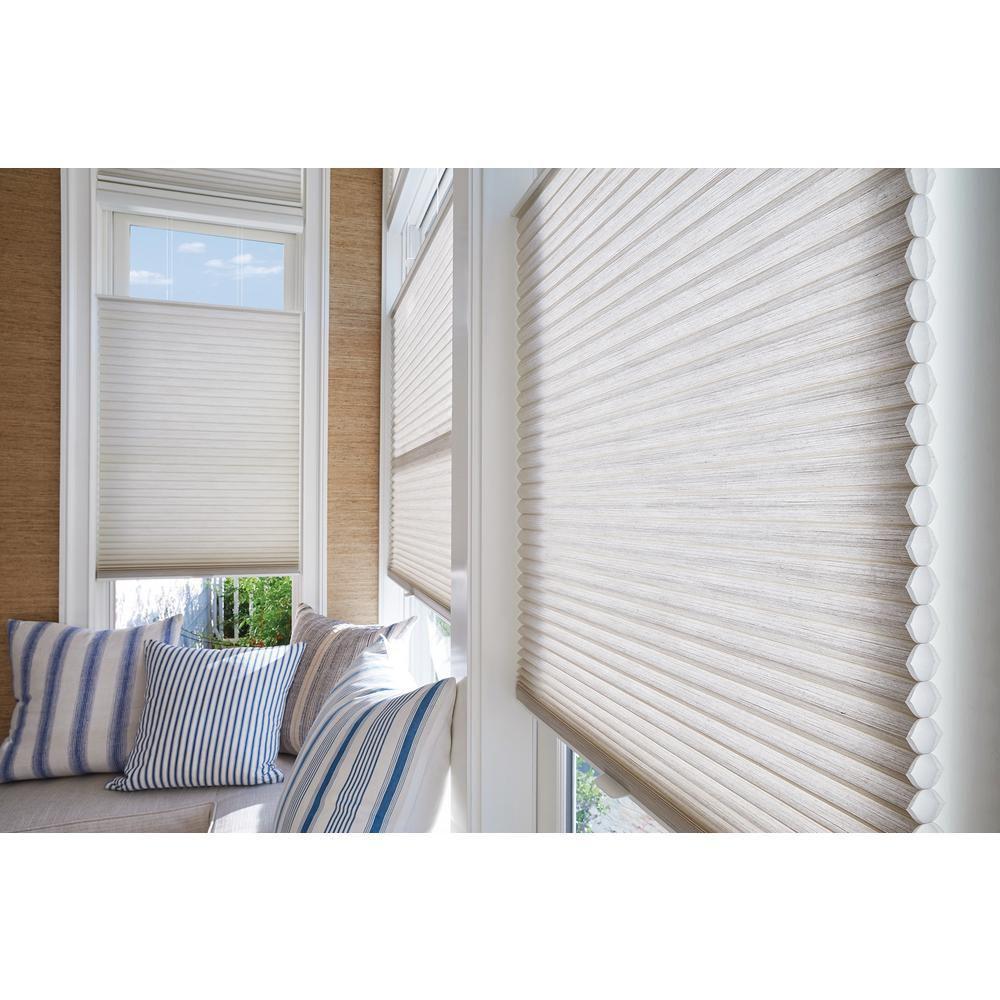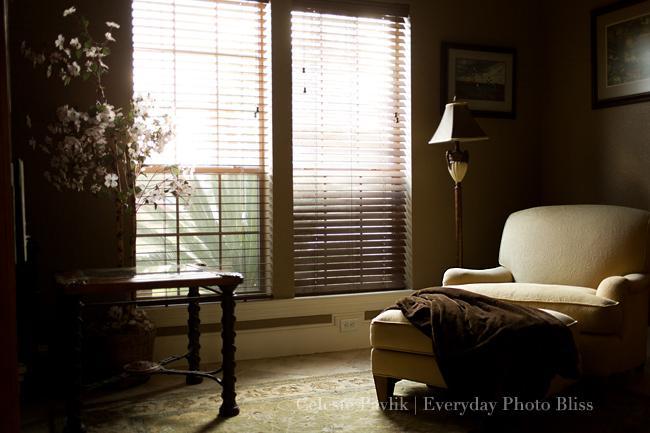The first image is the image on the left, the second image is the image on the right. Considering the images on both sides, is "There are five blinds." valid? Answer yes or no. Yes. 